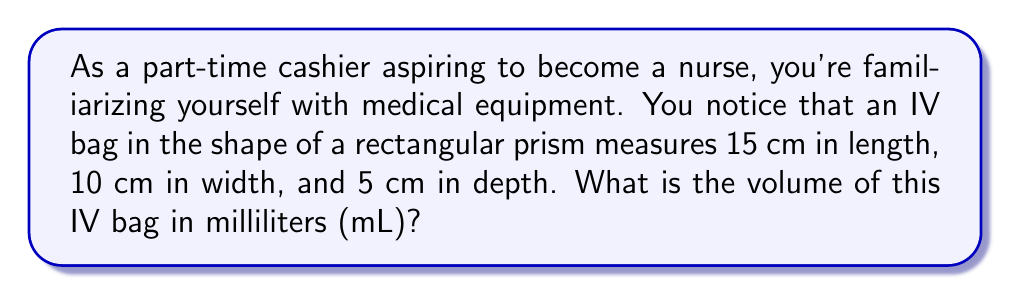Show me your answer to this math problem. To solve this problem, we need to follow these steps:

1. Identify the formula for the volume of a rectangular prism:
   $$V = l \times w \times d$$
   where $V$ is volume, $l$ is length, $w$ is width, and $d$ is depth.

2. Substitute the given dimensions into the formula:
   $$V = 15 \text{ cm} \times 10 \text{ cm} \times 5 \text{ cm}$$

3. Multiply the numbers:
   $$V = 750 \text{ cm}^3$$

4. Convert cubic centimeters to milliliters:
   Since 1 cm³ = 1 mL, the volume in milliliters is the same as the volume in cubic centimeters.

Therefore, the volume of the IV bag is 750 mL.
Answer: 750 mL 